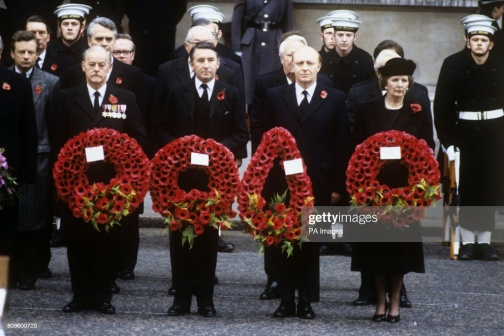Think of a very creative question related to this image. Get imaginative! If the wreaths in the image were enchanted and could whisper the names and stories of the individuals they represent, what tales of heroism, sacrifice, and history would they share with us? The enchanted wreaths, once bestowed with the power to narrate, would weave a tapestry of hauntingly beautiful stories. Each poppy would whisper a name, recounting a vivid scene from the lives of the heroes it symbolizes. One wreath might tell the tale of a courageous soldier who fearlessly led his platoon through treacherous battles, his bravery becoming a beacon of hope for his comrades. Another might recount the poignant story of a nurse who tirelessly tended to the wounded, her compassion and strength shining brightly amidst the chaos of war. The whispers would intermingle, creating a symphony of voices from the past, each contributing to the rich mosaic of history. The tales would speak of camaraderie forged in the crucible of conflict, of letters scribbled under starry skies, and of the unyielding hope that persevered through the darkest of times. These stories, filled with moments of triumph and heartache, would serve as a poignant reminder of the deep and enduring impact of their sacrifices, turning the solemn event into a celebration of heroism and an eternal tribute to their legacy. 